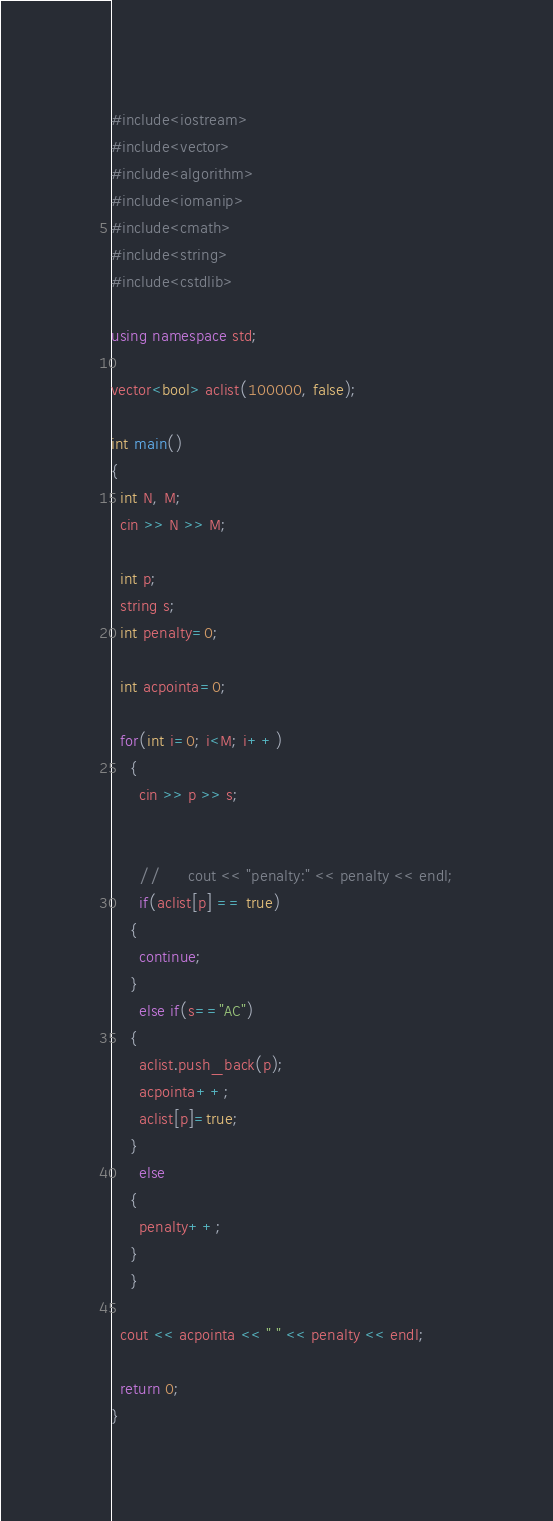<code> <loc_0><loc_0><loc_500><loc_500><_C++_>#include<iostream>
#include<vector>
#include<algorithm>
#include<iomanip>
#include<cmath>
#include<string>
#include<cstdlib>

using namespace std;

vector<bool> aclist(100000, false);

int main()
{
  int N, M;
  cin >> N >> M;

  int p;
  string s;
  int penalty=0;
  
  int acpointa=0;
  
  for(int i=0; i<M; i++)
    {
      cin >> p >> s;


      //      cout << "penalty:" << penalty << endl;
      if(aclist[p] == true)
	{
	  continue;
	}
      else if(s=="AC")
	{
	  aclist.push_back(p);
	  acpointa++;
	  aclist[p]=true;
	}
      else
	{
	  penalty++;
	}
    }
  
  cout << acpointa << " " << penalty << endl;

  return 0;
}
</code> 